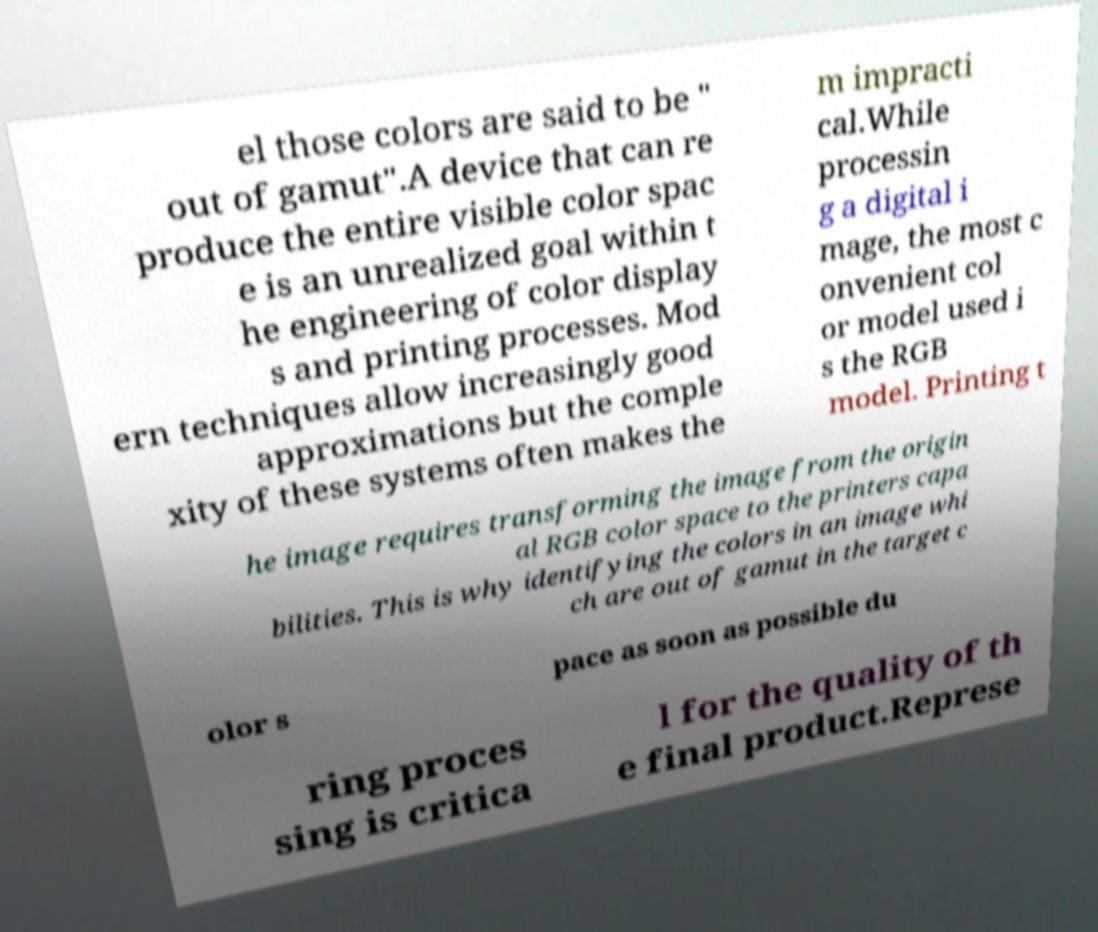Could you extract and type out the text from this image? el those colors are said to be " out of gamut".A device that can re produce the entire visible color spac e is an unrealized goal within t he engineering of color display s and printing processes. Mod ern techniques allow increasingly good approximations but the comple xity of these systems often makes the m impracti cal.While processin g a digital i mage, the most c onvenient col or model used i s the RGB model. Printing t he image requires transforming the image from the origin al RGB color space to the printers capa bilities. This is why identifying the colors in an image whi ch are out of gamut in the target c olor s pace as soon as possible du ring proces sing is critica l for the quality of th e final product.Represe 